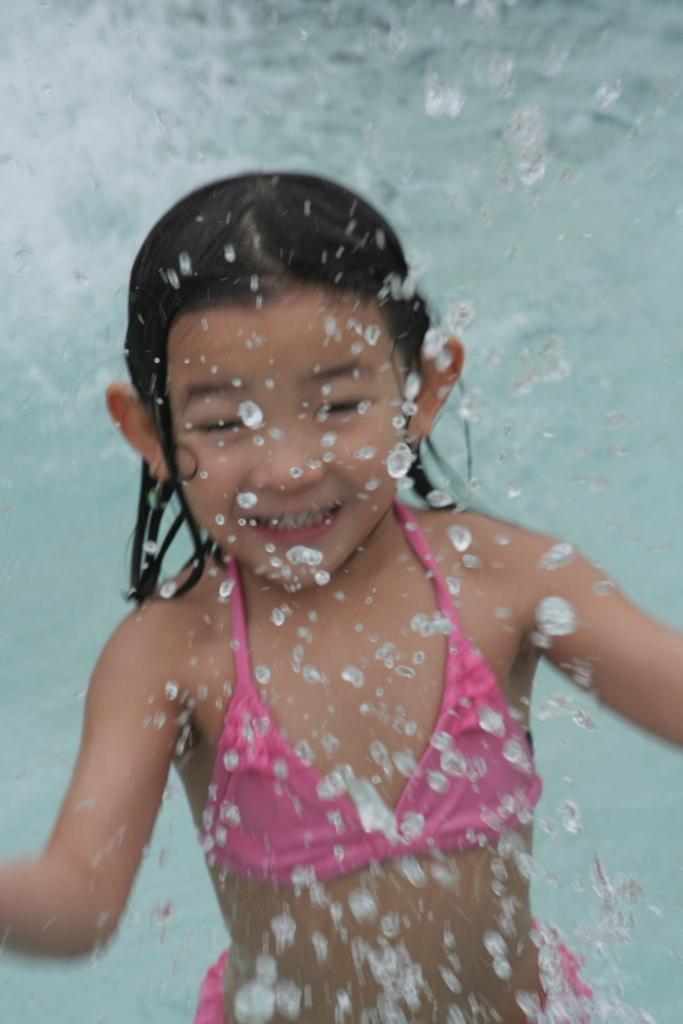How would you summarize this image in a sentence or two? In this image we can see a girl playing in the water. 